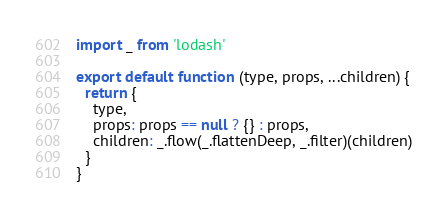Convert code to text. <code><loc_0><loc_0><loc_500><loc_500><_JavaScript_>import _ from 'lodash'

export default function (type, props, ...children) {
  return {
    type,
    props: props == null ? {} : props,
    children: _.flow(_.flattenDeep, _.filter)(children)
  }
}
</code> 